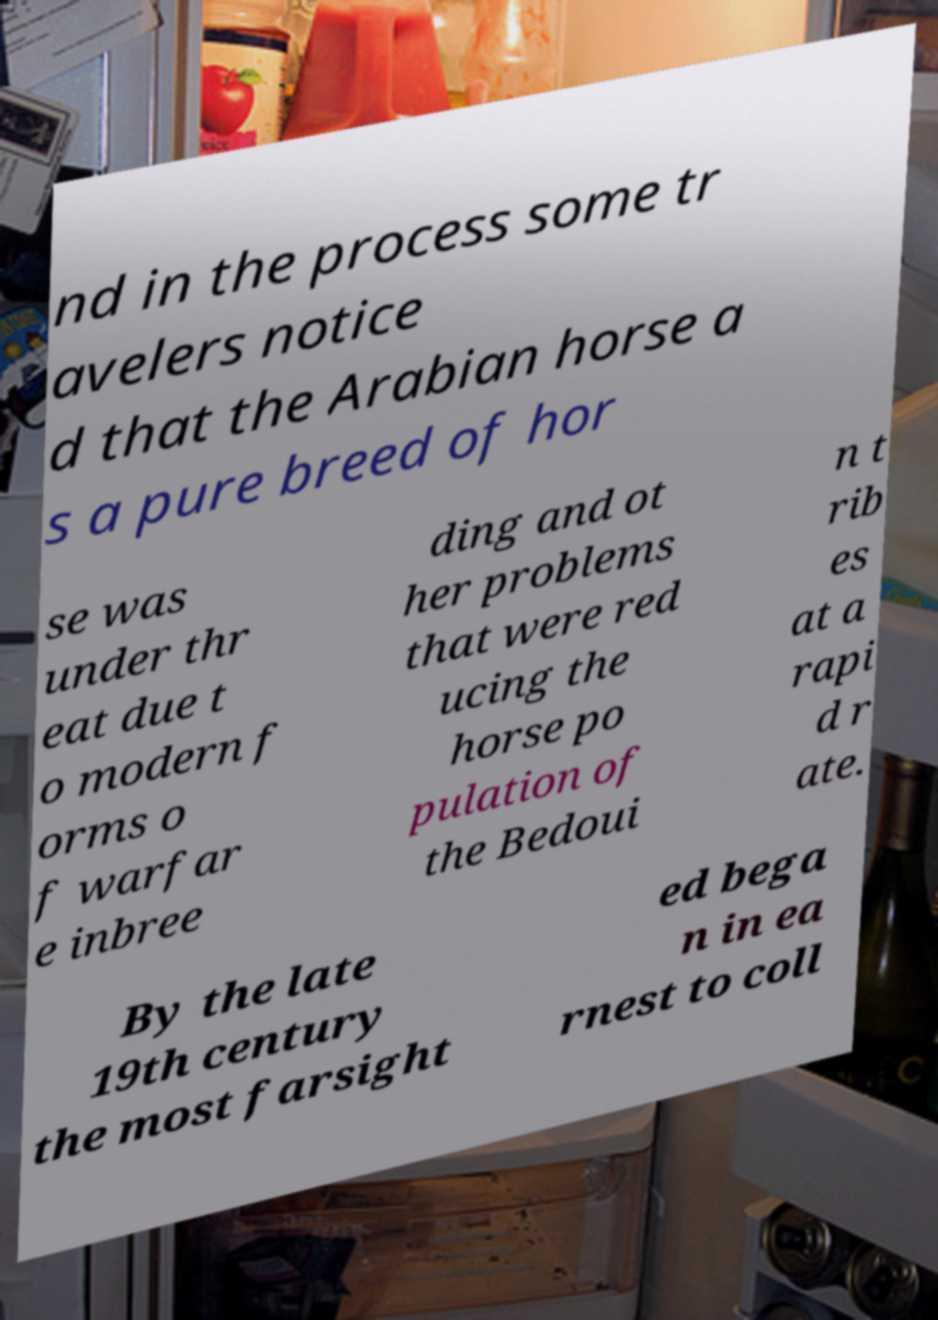For documentation purposes, I need the text within this image transcribed. Could you provide that? nd in the process some tr avelers notice d that the Arabian horse a s a pure breed of hor se was under thr eat due t o modern f orms o f warfar e inbree ding and ot her problems that were red ucing the horse po pulation of the Bedoui n t rib es at a rapi d r ate. By the late 19th century the most farsight ed bega n in ea rnest to coll 